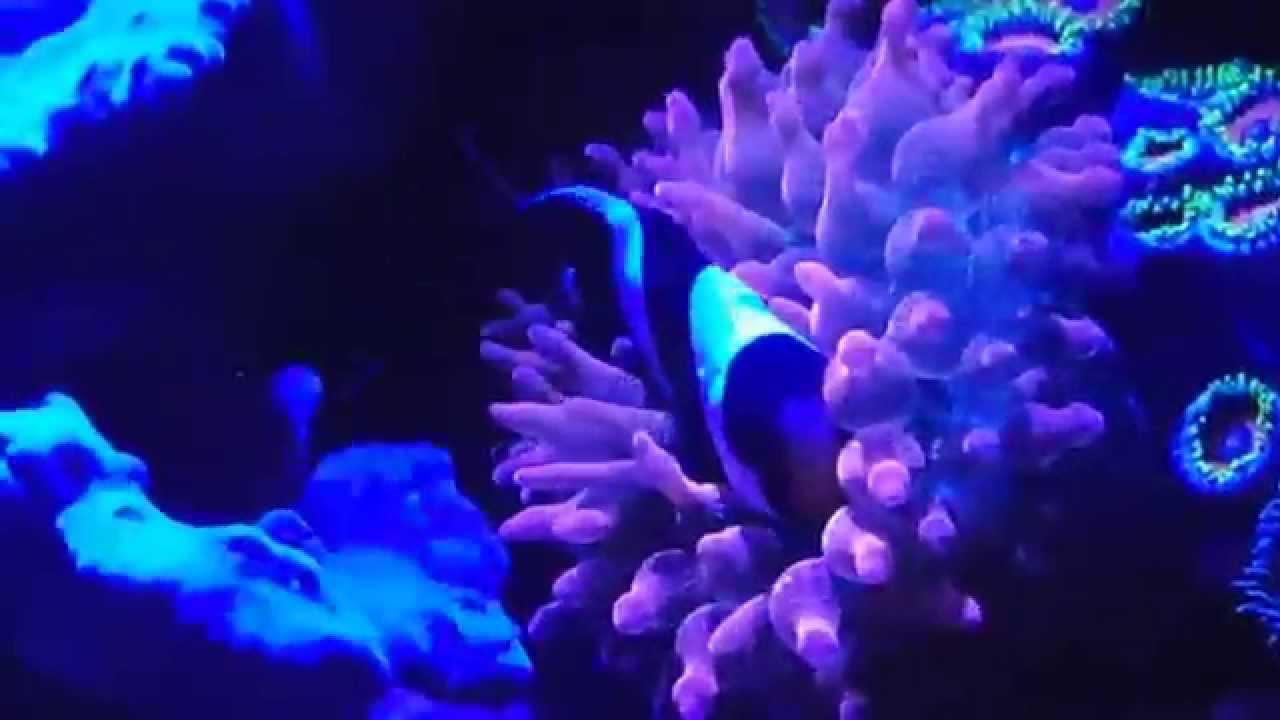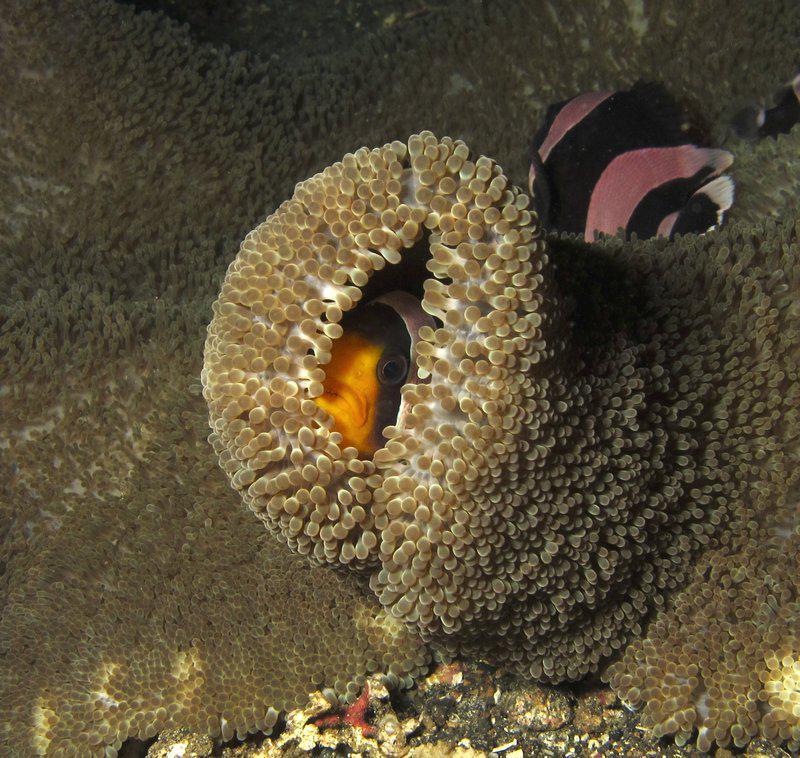The first image is the image on the left, the second image is the image on the right. For the images displayed, is the sentence "At least one image features a striped fish atop a purplish-blue anemone." factually correct? Answer yes or no. Yes. 